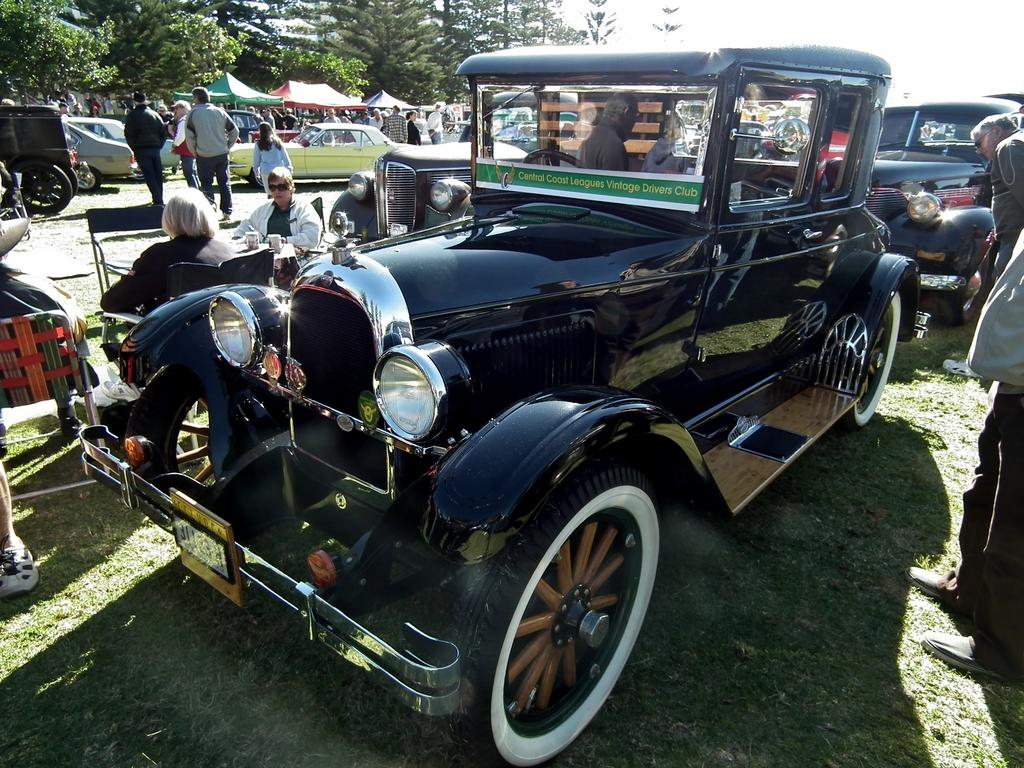Where was the image taken? The image was clicked outside. What can be seen at the top of the image? There are trees and stalls at the top of the image. What is in the middle of the image? There are vehicles and many persons in the middle of the image. What type of bells can be heard ringing in the image? There are no bells present in the image, and therefore no sound can be heard. 